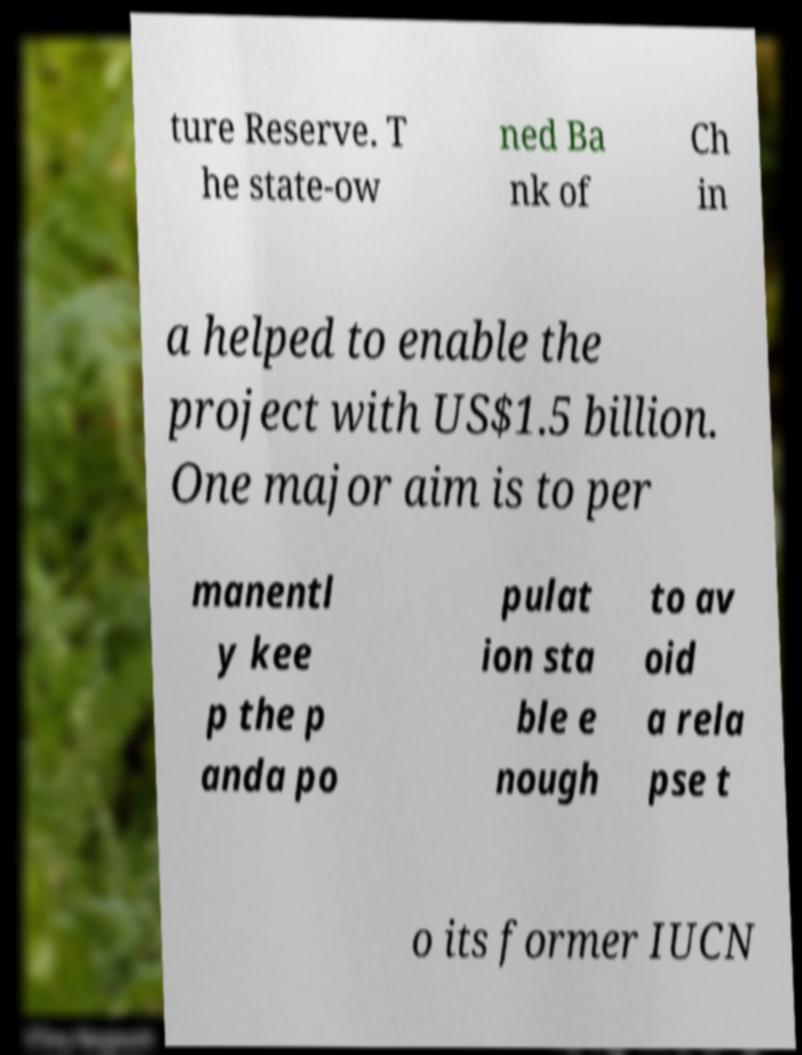What messages or text are displayed in this image? I need them in a readable, typed format. ture Reserve. T he state-ow ned Ba nk of Ch in a helped to enable the project with US$1.5 billion. One major aim is to per manentl y kee p the p anda po pulat ion sta ble e nough to av oid a rela pse t o its former IUCN 